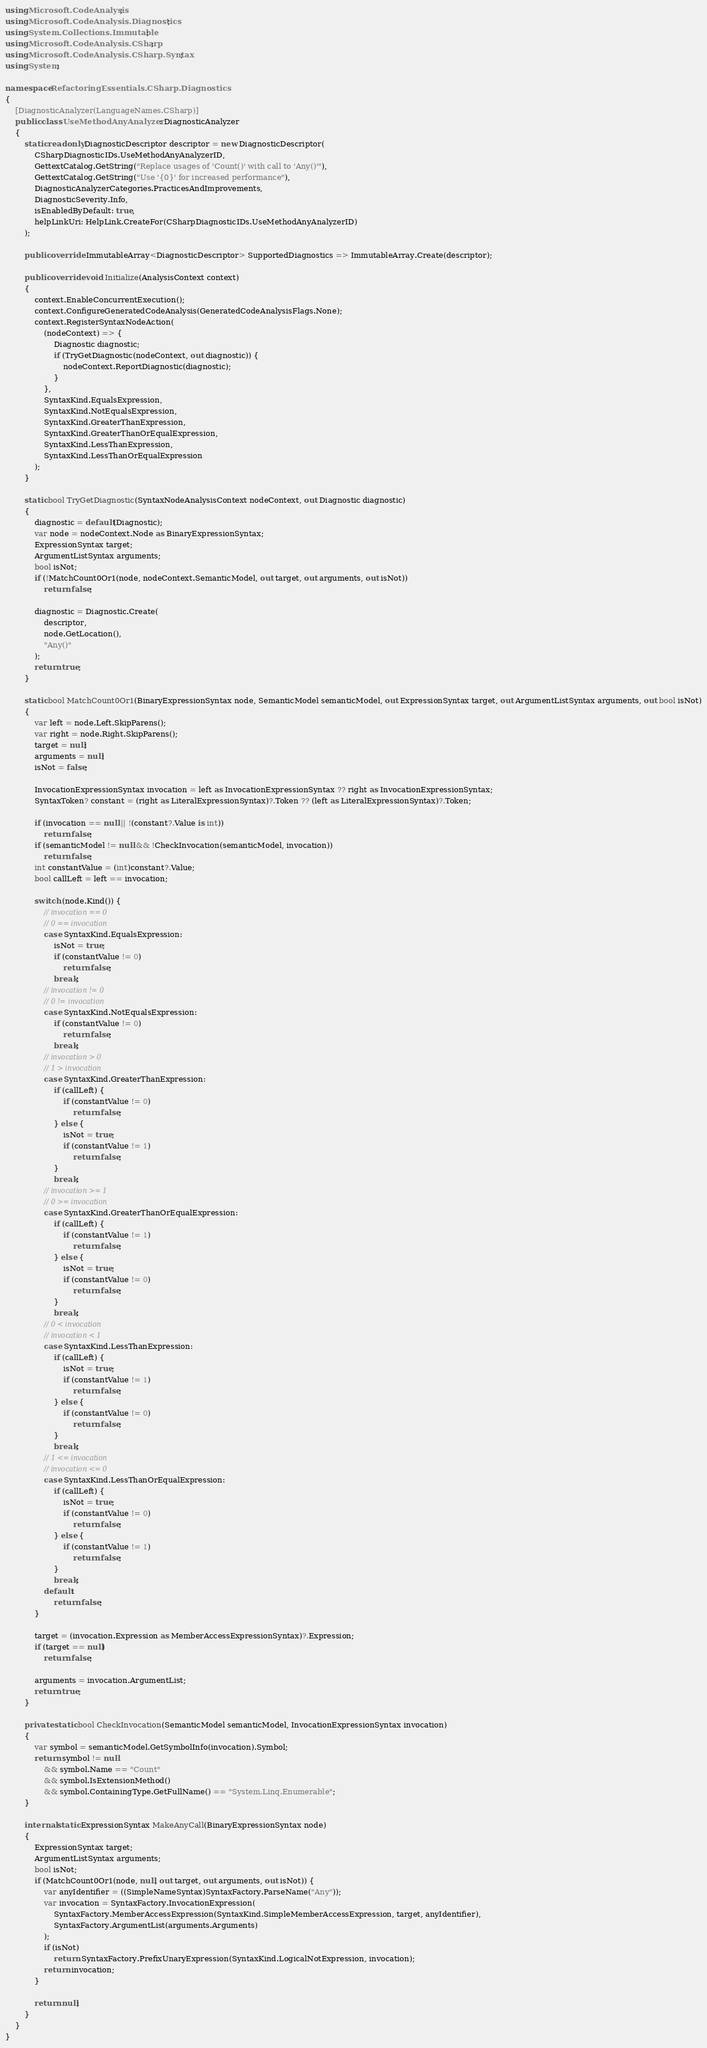<code> <loc_0><loc_0><loc_500><loc_500><_C#_>using Microsoft.CodeAnalysis;
using Microsoft.CodeAnalysis.Diagnostics;
using System.Collections.Immutable;
using Microsoft.CodeAnalysis.CSharp;
using Microsoft.CodeAnalysis.CSharp.Syntax;
using System;

namespace RefactoringEssentials.CSharp.Diagnostics
{
    [DiagnosticAnalyzer(LanguageNames.CSharp)]
    public class UseMethodAnyAnalyzer : DiagnosticAnalyzer
    {
        static readonly DiagnosticDescriptor descriptor = new DiagnosticDescriptor(
            CSharpDiagnosticIDs.UseMethodAnyAnalyzerID,
            GettextCatalog.GetString("Replace usages of 'Count()' with call to 'Any()'"),
            GettextCatalog.GetString("Use '{0}' for increased performance"),
            DiagnosticAnalyzerCategories.PracticesAndImprovements,
            DiagnosticSeverity.Info,
            isEnabledByDefault: true,
            helpLinkUri: HelpLink.CreateFor(CSharpDiagnosticIDs.UseMethodAnyAnalyzerID)
        );

        public override ImmutableArray<DiagnosticDescriptor> SupportedDiagnostics => ImmutableArray.Create(descriptor);

        public override void Initialize(AnalysisContext context)
        {
            context.EnableConcurrentExecution();
            context.ConfigureGeneratedCodeAnalysis(GeneratedCodeAnalysisFlags.None);
            context.RegisterSyntaxNodeAction(
                (nodeContext) => {
                    Diagnostic diagnostic;
                    if (TryGetDiagnostic(nodeContext, out diagnostic)) {
                        nodeContext.ReportDiagnostic(diagnostic);
                    }
                },
                SyntaxKind.EqualsExpression,
                SyntaxKind.NotEqualsExpression,
                SyntaxKind.GreaterThanExpression,
                SyntaxKind.GreaterThanOrEqualExpression,
                SyntaxKind.LessThanExpression,
                SyntaxKind.LessThanOrEqualExpression
            );
        }

        static bool TryGetDiagnostic(SyntaxNodeAnalysisContext nodeContext, out Diagnostic diagnostic)
        {
            diagnostic = default(Diagnostic);
            var node = nodeContext.Node as BinaryExpressionSyntax;
            ExpressionSyntax target;
            ArgumentListSyntax arguments;
            bool isNot;
            if (!MatchCount0Or1(node, nodeContext.SemanticModel, out target, out arguments, out isNot))
                return false;

            diagnostic = Diagnostic.Create(
                descriptor,
                node.GetLocation(),
                "Any()"
            );
            return true;
        }

        static bool MatchCount0Or1(BinaryExpressionSyntax node, SemanticModel semanticModel, out ExpressionSyntax target, out ArgumentListSyntax arguments, out bool isNot)
        {
            var left = node.Left.SkipParens();
            var right = node.Right.SkipParens();
            target = null;
            arguments = null;
            isNot = false;

            InvocationExpressionSyntax invocation = left as InvocationExpressionSyntax ?? right as InvocationExpressionSyntax;
            SyntaxToken? constant = (right as LiteralExpressionSyntax)?.Token ?? (left as LiteralExpressionSyntax)?.Token;

            if (invocation == null || !(constant?.Value is int))
                return false;
            if (semanticModel != null && !CheckInvocation(semanticModel, invocation))
                return false;
            int constantValue = (int)constant?.Value;
            bool callLeft = left == invocation;

            switch (node.Kind()) {
                // invocation == 0
                // 0 == invocation
                case SyntaxKind.EqualsExpression:
                    isNot = true;
                    if (constantValue != 0)
                        return false;
                    break;
                // invocation != 0
                // 0 != invocation
                case SyntaxKind.NotEqualsExpression:
                    if (constantValue != 0)
                        return false;
                    break;
                // invocation > 0
                // 1 > invocation
                case SyntaxKind.GreaterThanExpression:
                    if (callLeft) {
                        if (constantValue != 0)
                            return false;
                    } else {
                        isNot = true;
                        if (constantValue != 1)
                            return false;
                    }
                    break;
                // invocation >= 1
                // 0 >= invocation
                case SyntaxKind.GreaterThanOrEqualExpression:
                    if (callLeft) {
                        if (constantValue != 1)
                            return false;
                    } else {
                        isNot = true;
                        if (constantValue != 0)
                            return false;
                    }
                    break;
                // 0 < invocation
                // invocation < 1
                case SyntaxKind.LessThanExpression:
                    if (callLeft) {
                        isNot = true;
                        if (constantValue != 1)
                            return false;
                    } else {
                        if (constantValue != 0)
                            return false;
                    }
                    break;
                // 1 <= invocation
                // invocation <= 0
                case SyntaxKind.LessThanOrEqualExpression:
                    if (callLeft) {
                        isNot = true;
                        if (constantValue != 0)
                            return false;
                    } else {
                        if (constantValue != 1)
                            return false;
                    }
                    break;
                default:
                    return false;
            }

            target = (invocation.Expression as MemberAccessExpressionSyntax)?.Expression;
            if (target == null)
                return false;

            arguments = invocation.ArgumentList;
            return true;
        }

        private static bool CheckInvocation(SemanticModel semanticModel, InvocationExpressionSyntax invocation)
        {
            var symbol = semanticModel.GetSymbolInfo(invocation).Symbol;
            return symbol != null
                && symbol.Name == "Count"
                && symbol.IsExtensionMethod()
                && symbol.ContainingType.GetFullName() == "System.Linq.Enumerable";
        }

        internal static ExpressionSyntax MakeAnyCall(BinaryExpressionSyntax node)
        {
            ExpressionSyntax target;
            ArgumentListSyntax arguments;
            bool isNot;
            if (MatchCount0Or1(node, null, out target, out arguments, out isNot)) {
                var anyIdentifier = ((SimpleNameSyntax)SyntaxFactory.ParseName("Any"));
                var invocation = SyntaxFactory.InvocationExpression(
                    SyntaxFactory.MemberAccessExpression(SyntaxKind.SimpleMemberAccessExpression, target, anyIdentifier),
                    SyntaxFactory.ArgumentList(arguments.Arguments)
                );
                if (isNot)
                    return SyntaxFactory.PrefixUnaryExpression(SyntaxKind.LogicalNotExpression, invocation);
                return invocation;
            }

            return null;
        }
    }
}</code> 